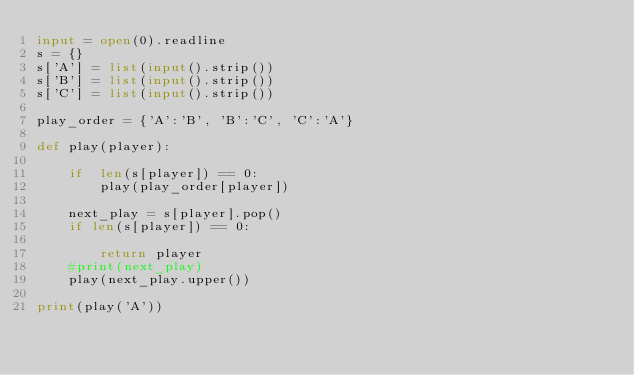Convert code to text. <code><loc_0><loc_0><loc_500><loc_500><_Python_>input = open(0).readline
s = {}
s['A'] = list(input().strip())
s['B'] = list(input().strip())
s['C'] = list(input().strip())

play_order = {'A':'B', 'B':'C', 'C':'A'}

def play(player):
    
    if  len(s[player]) == 0:
        play(play_order[player])
    
    next_play = s[player].pop()
    if len(s[player]) == 0:
        
        return player
    #print(next_play)
    play(next_play.upper())
        
print(play('A'))
        
        


</code> 